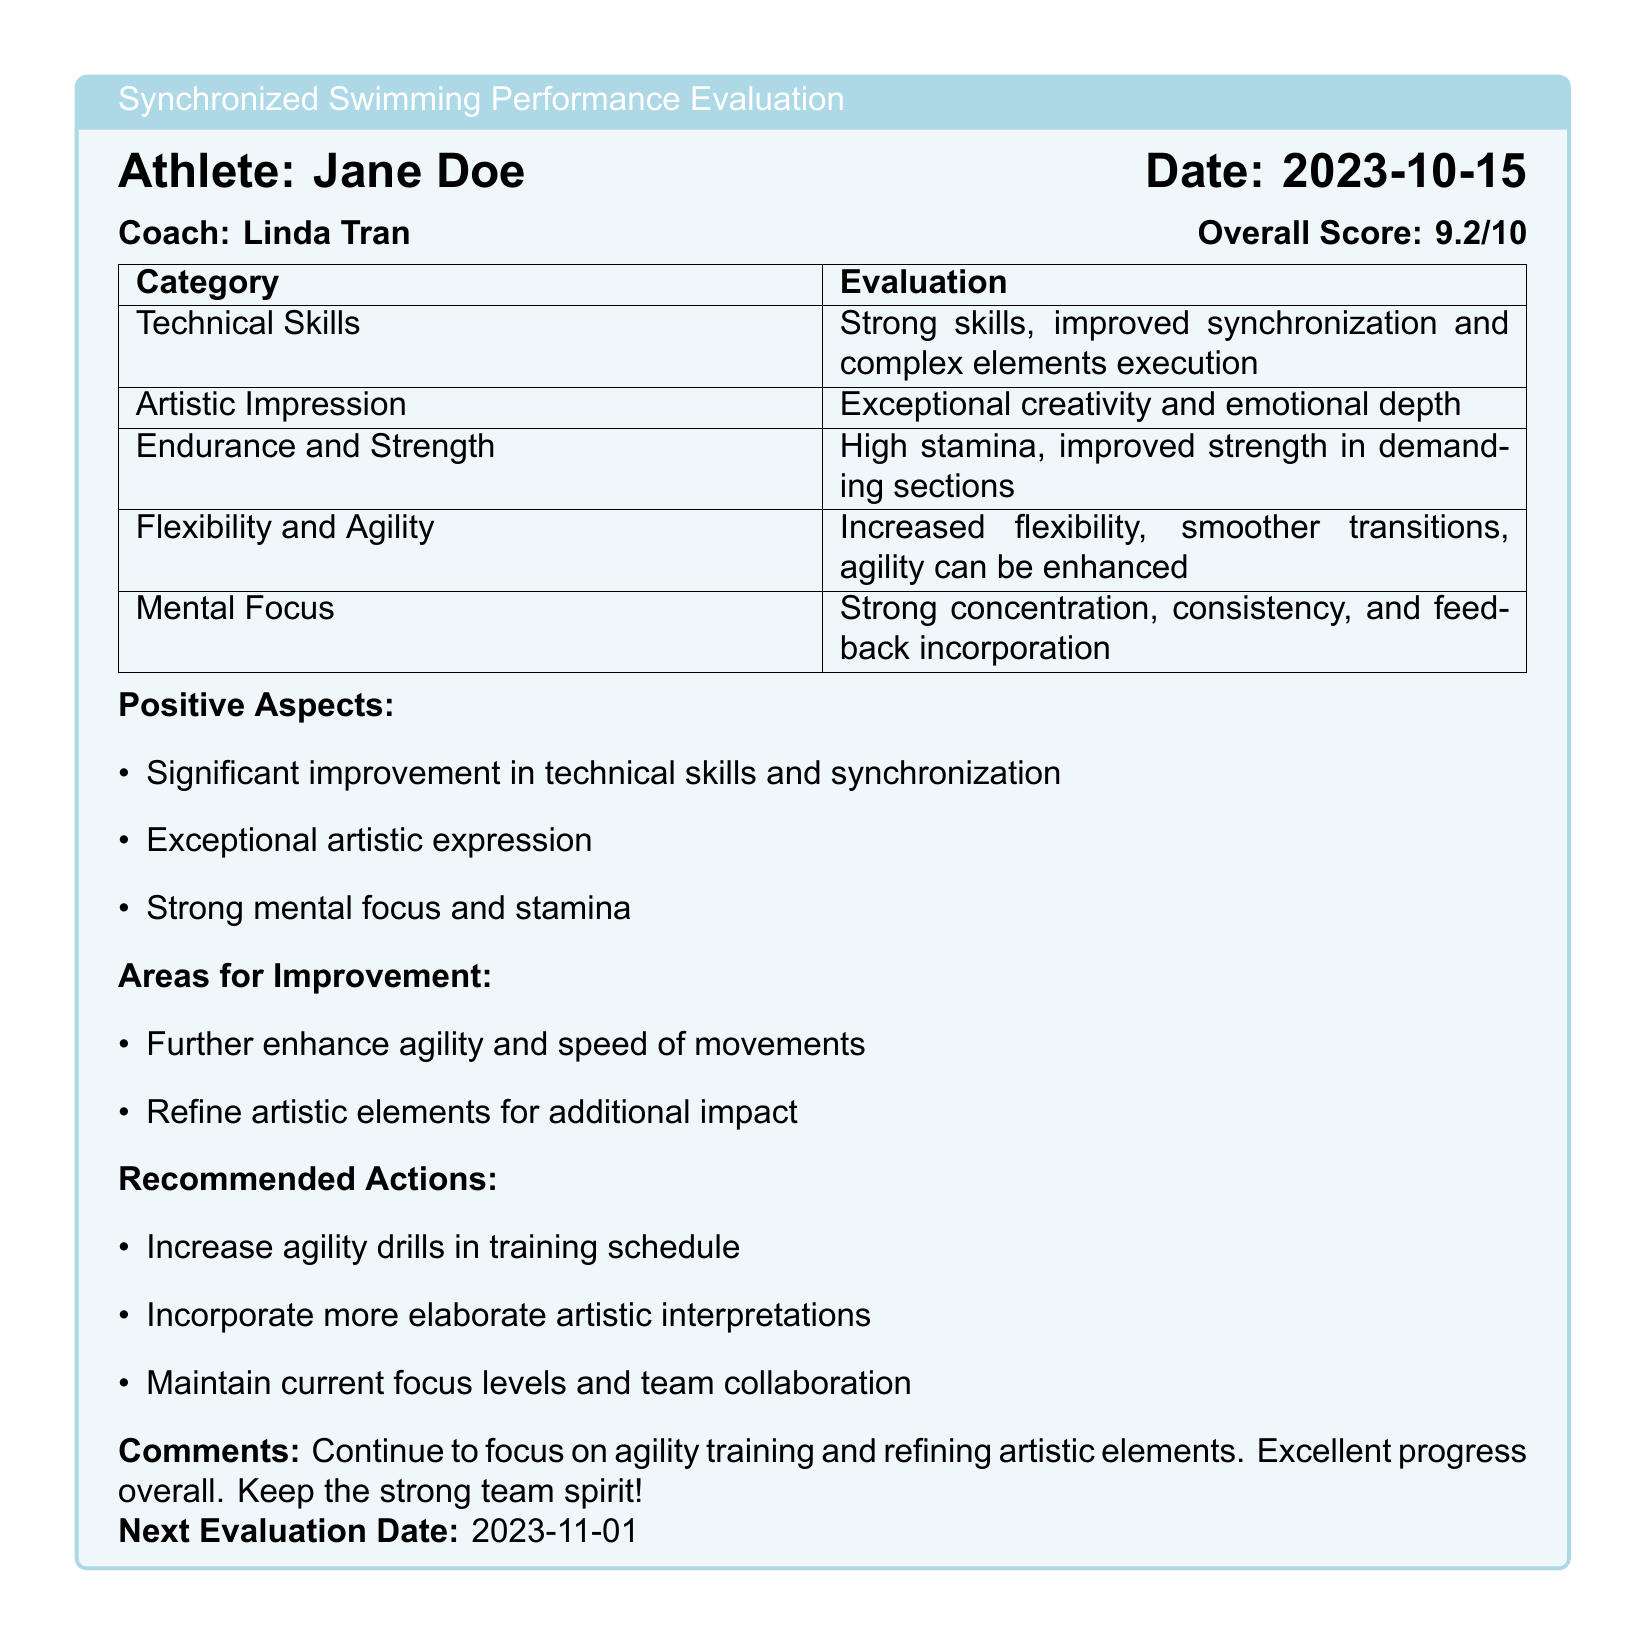What is the athlete's name? The athlete's name is mentioned at the top of the evaluation section.
Answer: Jane Doe Who is the coach? The coach's name is provided in the evaluation section.
Answer: Linda Tran What is the overall score? The overall score is shown in the evaluation box.
Answer: 9.2/10 What is the next evaluation date? The next evaluation date is noted at the bottom of the evaluation section.
Answer: 2023-11-01 What is one recommended action? This is listed under recommended actions in the evaluation.
Answer: Increase agility drills in training schedule Which location is used for water drills? The location of the water drills is specified in the training highlights.
Answer: Loyola Park Beach When do the full routine rehearsals take place? The timing of the full routine rehearsals is detailed in the training highlights.
Answer: Saturday 8:00-10:00 AM What is a special focus session? Special focus sessions are described in the training highlights.
Answer: Mental focus exercises with Dr. Alex Reed What are the positive aspects mentioned? The positive aspects are listed in the evaluation box.
Answer: Significant improvement in technical skills and synchronization 